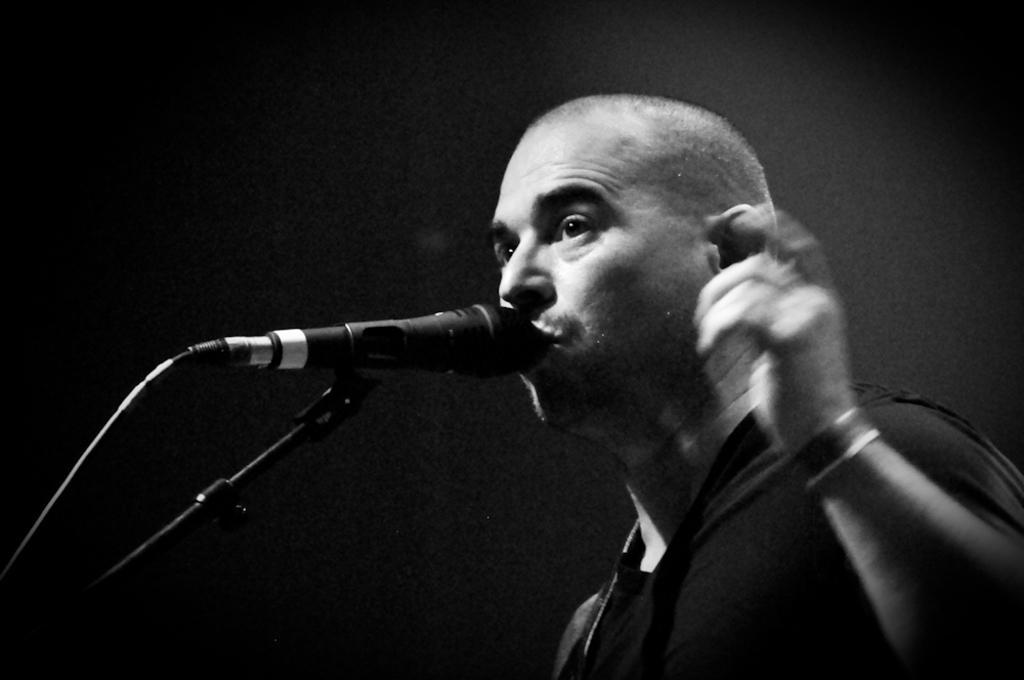In one or two sentences, can you explain what this image depicts? This is black and white picture where a man is present. In front of him mic is there. 